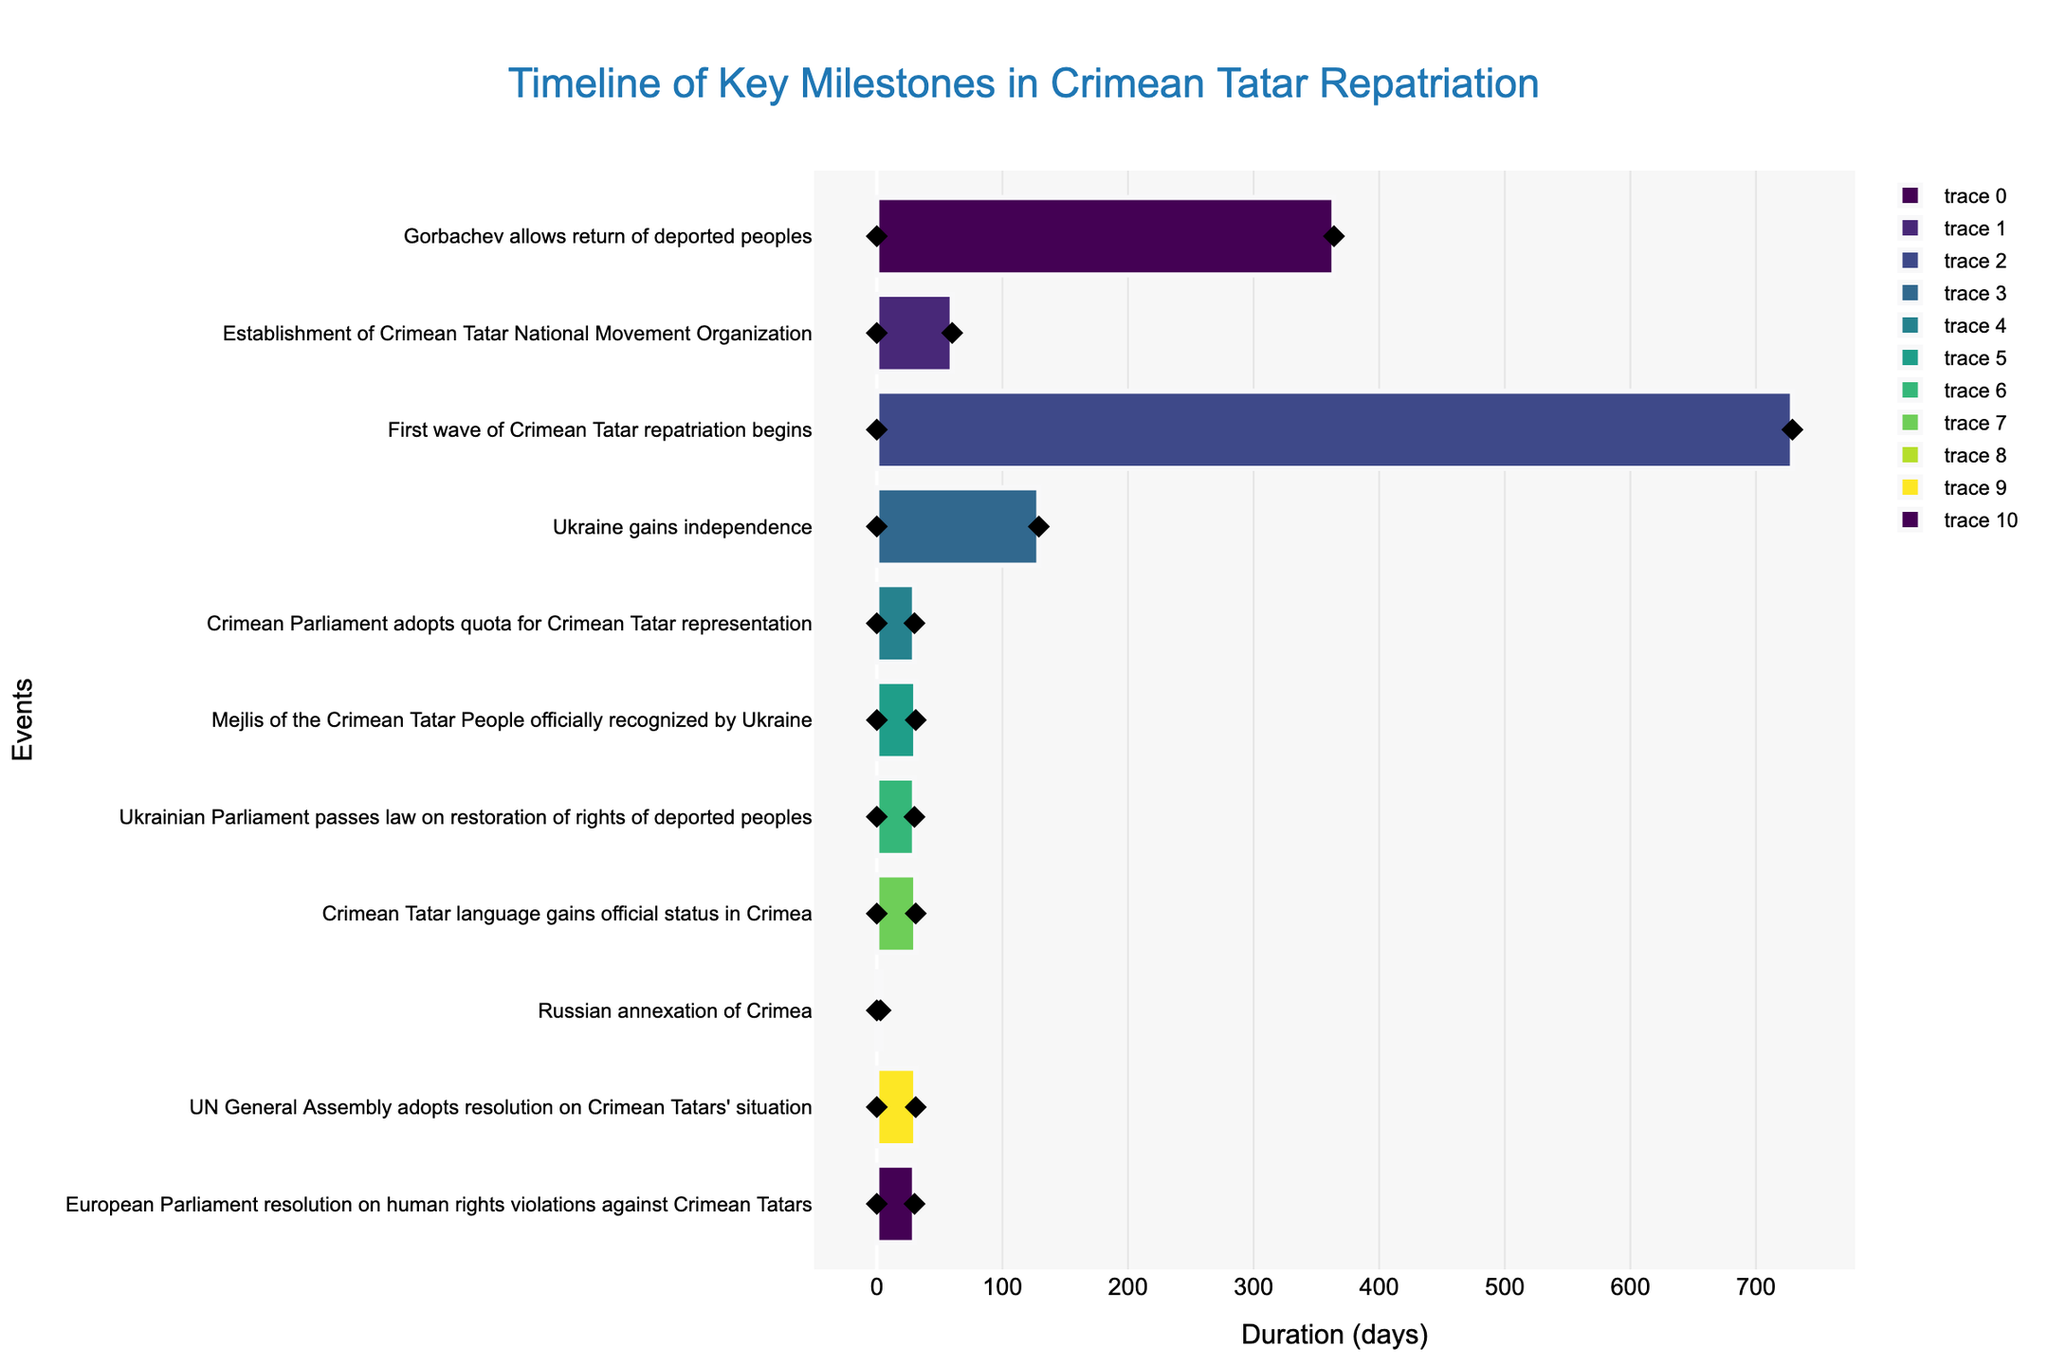How long did it take for the Crimean Tatar National Movement Organization to be established? According to the Gantt chart, the "Establishment of Crimean Tatar National Movement Organization" started on May 1, 1989, and ended on June 30, 1989. The duration is calculated as the number of days between these two dates.
Answer: 60 days Which event has the longest duration in the repatriation timeline? By analyzing the lengths of the bars representing each event, the "First wave of Crimean Tatar repatriation begins" has the longest duration, spanning from January 1, 1990, to December 31, 1991.
Answer: First wave of Crimean Tatar repatriation begins How many days did it take for the Russian annexation of Crimea? The "Russian annexation of Crimea" event started on March 18, 2014, and ended on March 21, 2014. The number of days between these dates is calculated.
Answer: 4 days Compare the duration of the "Ukrainian Parliament passes law on restoration of rights of deported peoples" with the "Crimean Parliament adopts quota for Crimean Tatar representation" timeline. Which one took longer? The timeline for "Ukrainian Parliament passes law on restoration of rights of deported peoples" is from April 20, 2004, to May 20, 2004, lasting 31 days. The "Crimean Parliament adopts quota for Crimean Tatar representation" spans from September 14, 1993, to October 14, 1993, also lasting 31 days. Both events took the same amount of time.
Answer: Both took the same amount of time Following Ukraine's independence, what was the next major event in the timeline? The chart shows that Ukraine gained independence on August 24, 1991. The next major event after this is the "Crimean Parliament adopts quota for Crimean Tatar representation" on September 14, 1993.
Answer: Crimean Parliament adopts quota for Crimean Tatar representation Calculate the total number of days covered by events from 2000 to 2010. In the given timeline, the event within this period is "Crimean Tatar language gains official status in Crimea" from August 10, 2010, to September 10, 2010, lasting 31 days.
Answer: 31 days What are the start and end dates of the Mejlis recognition event? According to the Gantt chart, the "Mejlis of the Crimean Tatar People officially recognized by Ukraine" started on May 18, 1999, and ended on June 18, 1999.
Answer: May 18, 1999, to June 18, 1999 Which event immediately precedes the UN General Assembly adopting a resolution on Crimean Tatars' situation? The event just before the "UN General Assembly adopts resolution on Crimean Tatars' situation" (Dec 19, 2016 - Jan 19, 2017) is the "Russian annexation of Crimea" (March 18, 2014 - March 21, 2014).
Answer: Russian annexation of Crimea How long did it take for the Crimean Tatar language to gain official status after Gorbachev allowed the return of deported peoples? Gorbachev allowed the return of deported peoples in 1989. The Crimean Tatar language gained official status on August 10, 2010. The gap between these events is from 1989 to 2010.
Answer: 21 years 